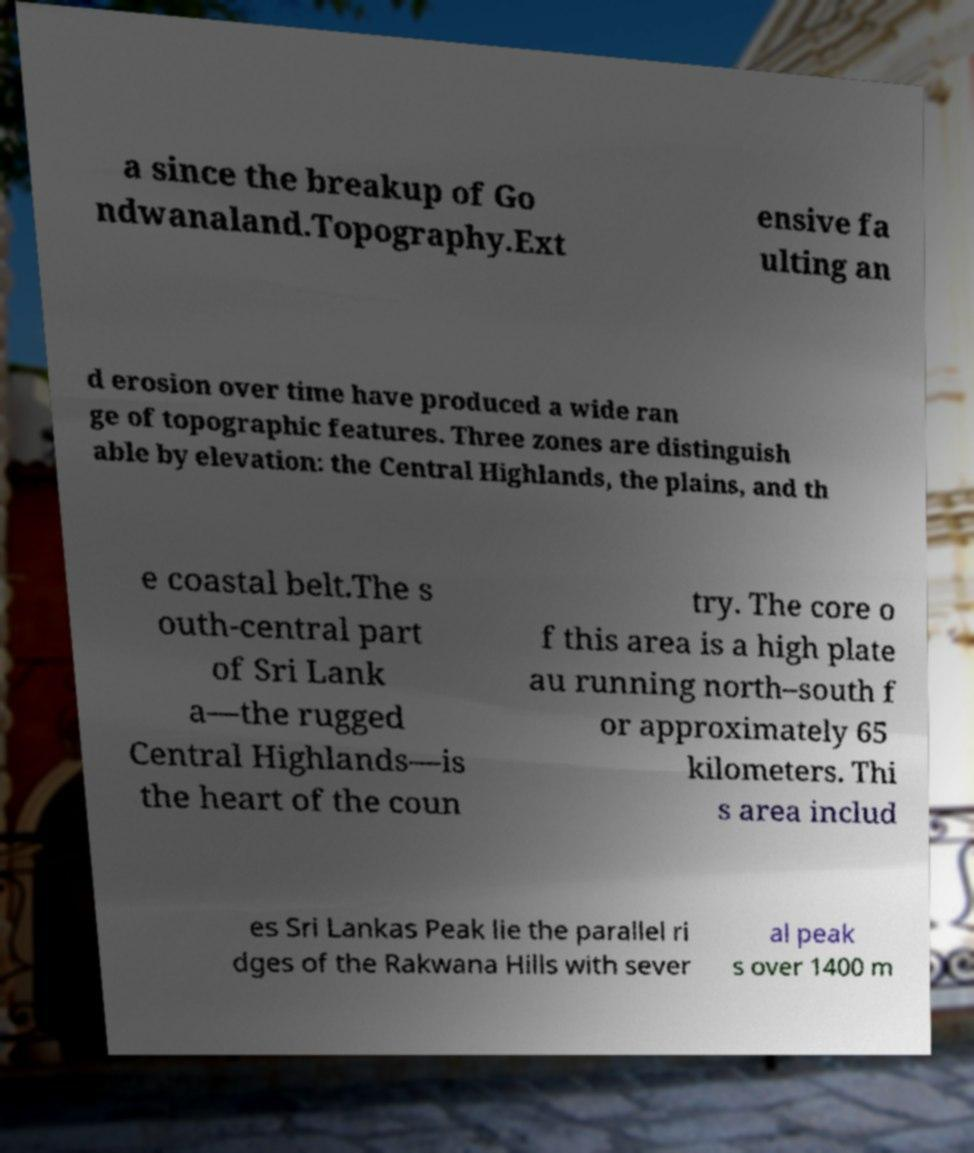Please read and relay the text visible in this image. What does it say? a since the breakup of Go ndwanaland.Topography.Ext ensive fa ulting an d erosion over time have produced a wide ran ge of topographic features. Three zones are distinguish able by elevation: the Central Highlands, the plains, and th e coastal belt.The s outh-central part of Sri Lank a—the rugged Central Highlands—is the heart of the coun try. The core o f this area is a high plate au running north–south f or approximately 65 kilometers. Thi s area includ es Sri Lankas Peak lie the parallel ri dges of the Rakwana Hills with sever al peak s over 1400 m 